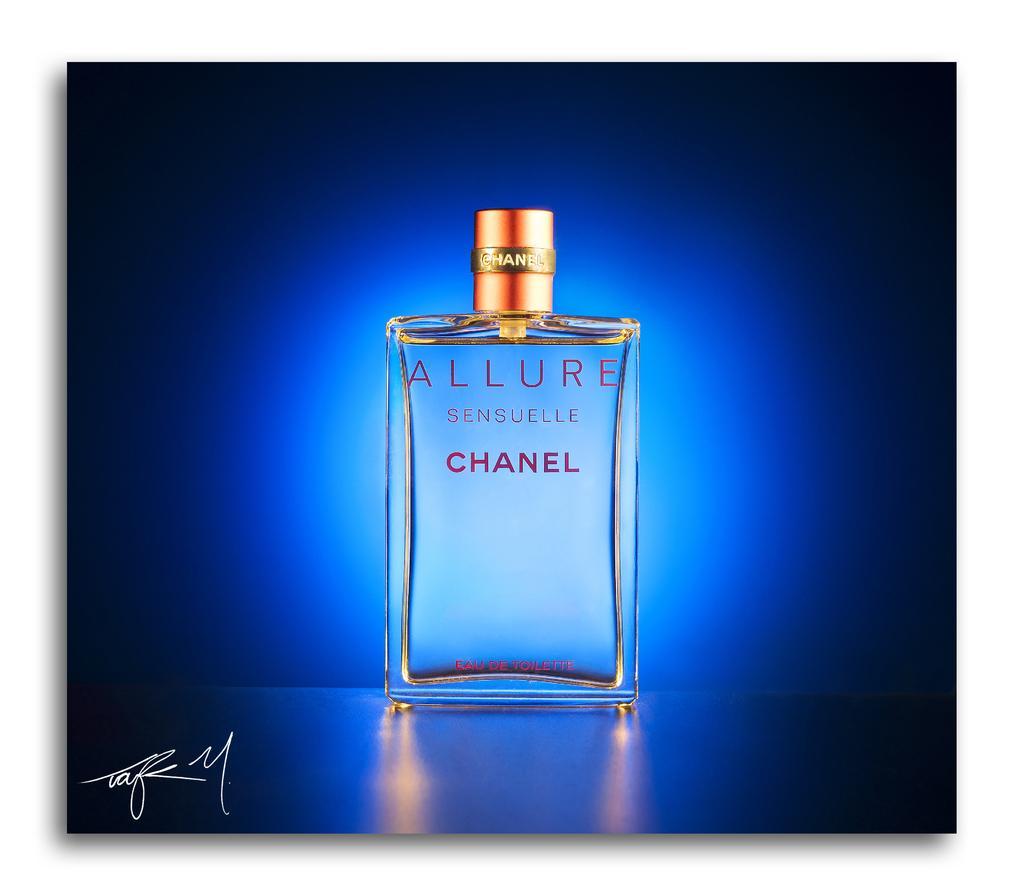How would you summarize this image in a sentence or two? I think this is looking a perfume bottle. 